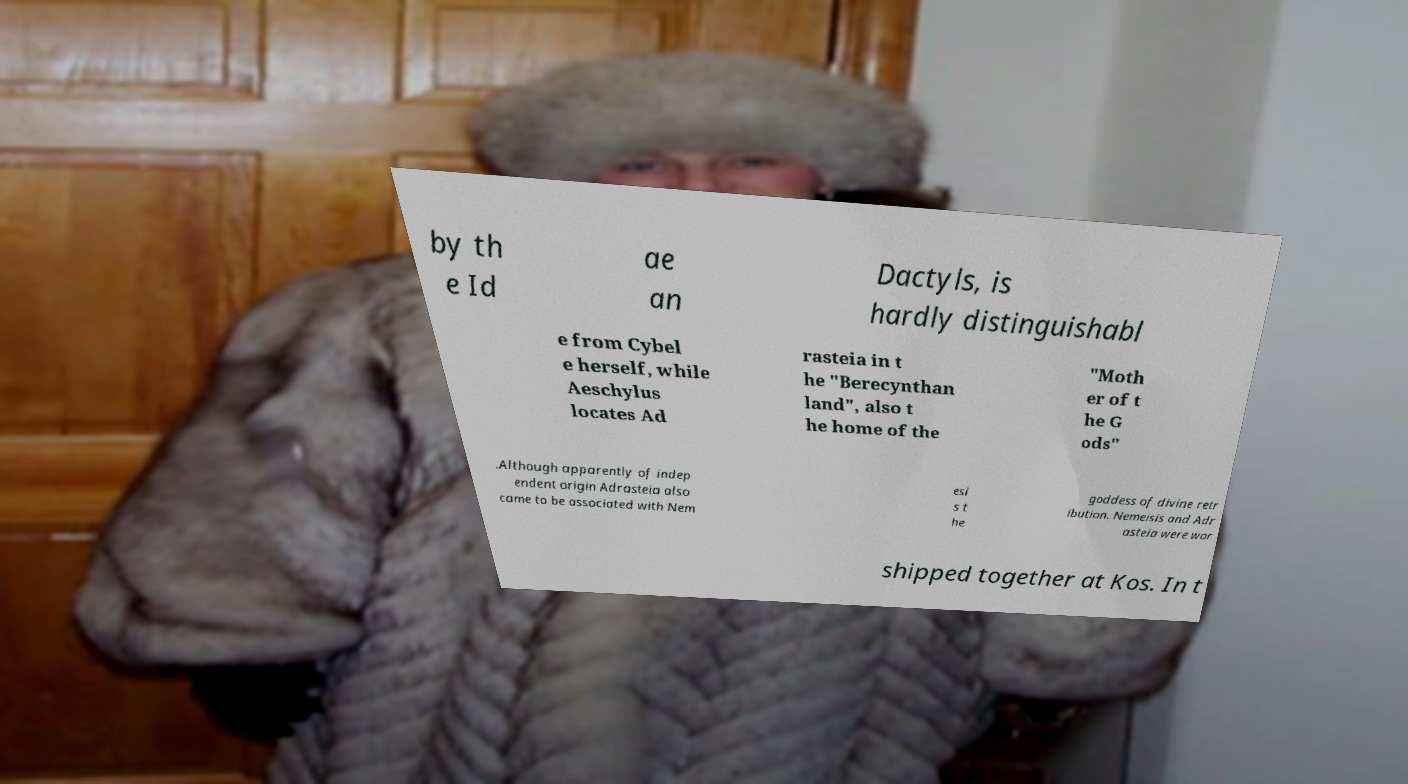Could you assist in decoding the text presented in this image and type it out clearly? by th e Id ae an Dactyls, is hardly distinguishabl e from Cybel e herself, while Aeschylus locates Ad rasteia in t he "Berecynthan land", also t he home of the "Moth er of t he G ods" .Although apparently of indep endent origin Adrasteia also came to be associated with Nem esi s t he goddess of divine retr ibution. Nemeisis and Adr asteia were wor shipped together at Kos. In t 